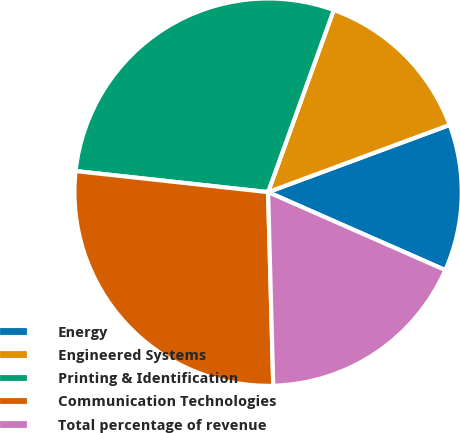Convert chart to OTSL. <chart><loc_0><loc_0><loc_500><loc_500><pie_chart><fcel>Energy<fcel>Engineered Systems<fcel>Printing & Identification<fcel>Communication Technologies<fcel>Total percentage of revenue<nl><fcel>12.24%<fcel>13.85%<fcel>28.77%<fcel>27.16%<fcel>17.98%<nl></chart> 